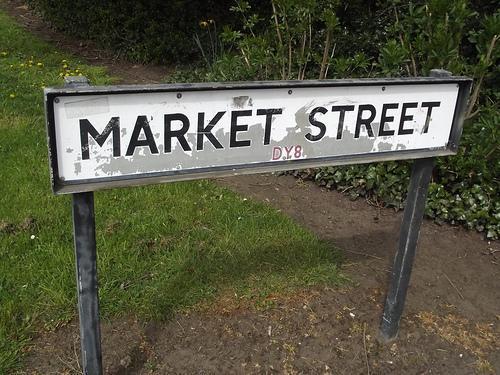How many signs are there?
Give a very brief answer. 1. 